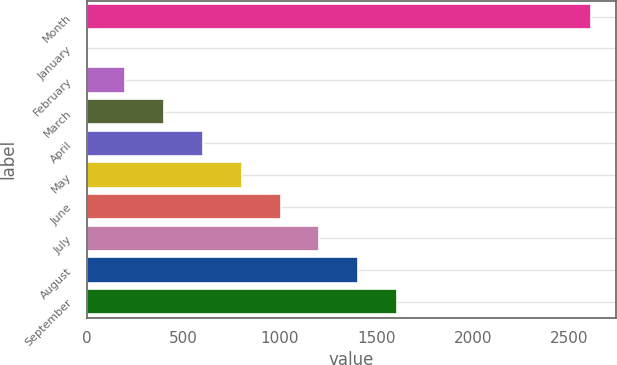<chart> <loc_0><loc_0><loc_500><loc_500><bar_chart><fcel>Month<fcel>January<fcel>February<fcel>March<fcel>April<fcel>May<fcel>June<fcel>July<fcel>August<fcel>September<nl><fcel>2613.01<fcel>0.14<fcel>201.13<fcel>402.12<fcel>603.11<fcel>804.1<fcel>1005.09<fcel>1206.08<fcel>1407.07<fcel>1608.06<nl></chart> 